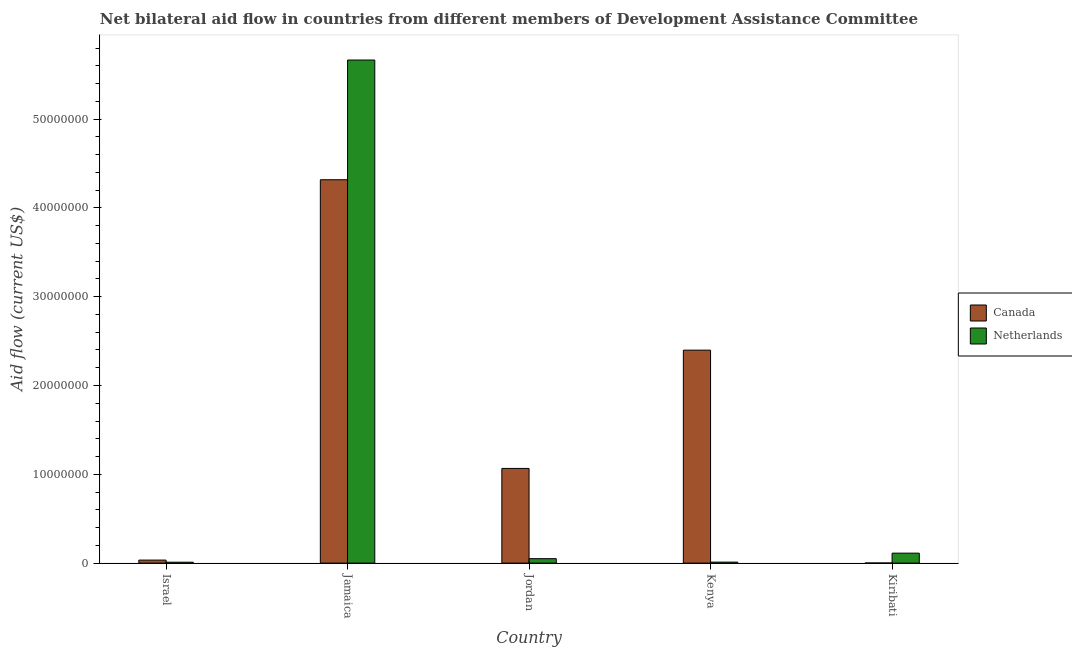What is the label of the 2nd group of bars from the left?
Your response must be concise. Jamaica. What is the amount of aid given by canada in Israel?
Your answer should be very brief. 3.40e+05. Across all countries, what is the maximum amount of aid given by netherlands?
Ensure brevity in your answer.  5.66e+07. Across all countries, what is the minimum amount of aid given by canada?
Your answer should be compact. 10000. In which country was the amount of aid given by netherlands maximum?
Keep it short and to the point. Jamaica. In which country was the amount of aid given by canada minimum?
Make the answer very short. Kiribati. What is the total amount of aid given by netherlands in the graph?
Your answer should be very brief. 5.85e+07. What is the difference between the amount of aid given by netherlands in Jamaica and that in Kiribati?
Your answer should be compact. 5.55e+07. What is the difference between the amount of aid given by netherlands in Kenya and the amount of aid given by canada in Jamaica?
Keep it short and to the point. -4.31e+07. What is the average amount of aid given by netherlands per country?
Provide a short and direct response. 1.17e+07. What is the difference between the amount of aid given by netherlands and amount of aid given by canada in Jordan?
Make the answer very short. -1.02e+07. In how many countries, is the amount of aid given by canada greater than 44000000 US$?
Your response must be concise. 0. What is the ratio of the amount of aid given by canada in Jamaica to that in Kenya?
Provide a succinct answer. 1.8. Is the amount of aid given by canada in Israel less than that in Jordan?
Ensure brevity in your answer.  Yes. Is the difference between the amount of aid given by netherlands in Israel and Kiribati greater than the difference between the amount of aid given by canada in Israel and Kiribati?
Make the answer very short. No. What is the difference between the highest and the second highest amount of aid given by canada?
Your response must be concise. 1.92e+07. What is the difference between the highest and the lowest amount of aid given by netherlands?
Provide a short and direct response. 5.66e+07. What does the 1st bar from the right in Kenya represents?
Ensure brevity in your answer.  Netherlands. How many bars are there?
Ensure brevity in your answer.  10. Are all the bars in the graph horizontal?
Provide a short and direct response. No. How many countries are there in the graph?
Keep it short and to the point. 5. Does the graph contain any zero values?
Your answer should be compact. No. Where does the legend appear in the graph?
Offer a very short reply. Center right. What is the title of the graph?
Give a very brief answer. Net bilateral aid flow in countries from different members of Development Assistance Committee. Does "All education staff compensation" appear as one of the legend labels in the graph?
Provide a short and direct response. No. What is the label or title of the X-axis?
Offer a terse response. Country. What is the Aid flow (current US$) of Canada in Israel?
Offer a very short reply. 3.40e+05. What is the Aid flow (current US$) of Netherlands in Israel?
Offer a terse response. 1.00e+05. What is the Aid flow (current US$) of Canada in Jamaica?
Provide a short and direct response. 4.32e+07. What is the Aid flow (current US$) in Netherlands in Jamaica?
Provide a short and direct response. 5.66e+07. What is the Aid flow (current US$) of Canada in Jordan?
Your answer should be very brief. 1.07e+07. What is the Aid flow (current US$) in Canada in Kenya?
Provide a short and direct response. 2.40e+07. What is the Aid flow (current US$) of Netherlands in Kenya?
Your answer should be very brief. 1.10e+05. What is the Aid flow (current US$) in Canada in Kiribati?
Offer a very short reply. 10000. What is the Aid flow (current US$) in Netherlands in Kiribati?
Provide a short and direct response. 1.12e+06. Across all countries, what is the maximum Aid flow (current US$) of Canada?
Offer a very short reply. 4.32e+07. Across all countries, what is the maximum Aid flow (current US$) of Netherlands?
Your answer should be very brief. 5.66e+07. What is the total Aid flow (current US$) in Canada in the graph?
Give a very brief answer. 7.82e+07. What is the total Aid flow (current US$) of Netherlands in the graph?
Ensure brevity in your answer.  5.85e+07. What is the difference between the Aid flow (current US$) of Canada in Israel and that in Jamaica?
Your answer should be compact. -4.28e+07. What is the difference between the Aid flow (current US$) in Netherlands in Israel and that in Jamaica?
Ensure brevity in your answer.  -5.66e+07. What is the difference between the Aid flow (current US$) in Canada in Israel and that in Jordan?
Make the answer very short. -1.03e+07. What is the difference between the Aid flow (current US$) in Netherlands in Israel and that in Jordan?
Your answer should be compact. -4.00e+05. What is the difference between the Aid flow (current US$) in Canada in Israel and that in Kenya?
Your response must be concise. -2.36e+07. What is the difference between the Aid flow (current US$) of Netherlands in Israel and that in Kenya?
Provide a short and direct response. -10000. What is the difference between the Aid flow (current US$) of Canada in Israel and that in Kiribati?
Your response must be concise. 3.30e+05. What is the difference between the Aid flow (current US$) in Netherlands in Israel and that in Kiribati?
Give a very brief answer. -1.02e+06. What is the difference between the Aid flow (current US$) in Canada in Jamaica and that in Jordan?
Offer a terse response. 3.25e+07. What is the difference between the Aid flow (current US$) of Netherlands in Jamaica and that in Jordan?
Offer a very short reply. 5.62e+07. What is the difference between the Aid flow (current US$) in Canada in Jamaica and that in Kenya?
Keep it short and to the point. 1.92e+07. What is the difference between the Aid flow (current US$) of Netherlands in Jamaica and that in Kenya?
Your answer should be very brief. 5.65e+07. What is the difference between the Aid flow (current US$) of Canada in Jamaica and that in Kiribati?
Your response must be concise. 4.32e+07. What is the difference between the Aid flow (current US$) in Netherlands in Jamaica and that in Kiribati?
Give a very brief answer. 5.55e+07. What is the difference between the Aid flow (current US$) of Canada in Jordan and that in Kenya?
Your answer should be very brief. -1.33e+07. What is the difference between the Aid flow (current US$) of Canada in Jordan and that in Kiribati?
Keep it short and to the point. 1.06e+07. What is the difference between the Aid flow (current US$) in Netherlands in Jordan and that in Kiribati?
Ensure brevity in your answer.  -6.20e+05. What is the difference between the Aid flow (current US$) of Canada in Kenya and that in Kiribati?
Keep it short and to the point. 2.40e+07. What is the difference between the Aid flow (current US$) in Netherlands in Kenya and that in Kiribati?
Your response must be concise. -1.01e+06. What is the difference between the Aid flow (current US$) in Canada in Israel and the Aid flow (current US$) in Netherlands in Jamaica?
Make the answer very short. -5.63e+07. What is the difference between the Aid flow (current US$) of Canada in Israel and the Aid flow (current US$) of Netherlands in Jordan?
Make the answer very short. -1.60e+05. What is the difference between the Aid flow (current US$) in Canada in Israel and the Aid flow (current US$) in Netherlands in Kiribati?
Ensure brevity in your answer.  -7.80e+05. What is the difference between the Aid flow (current US$) of Canada in Jamaica and the Aid flow (current US$) of Netherlands in Jordan?
Your response must be concise. 4.27e+07. What is the difference between the Aid flow (current US$) of Canada in Jamaica and the Aid flow (current US$) of Netherlands in Kenya?
Make the answer very short. 4.31e+07. What is the difference between the Aid flow (current US$) of Canada in Jamaica and the Aid flow (current US$) of Netherlands in Kiribati?
Your answer should be compact. 4.20e+07. What is the difference between the Aid flow (current US$) in Canada in Jordan and the Aid flow (current US$) in Netherlands in Kenya?
Your answer should be compact. 1.06e+07. What is the difference between the Aid flow (current US$) of Canada in Jordan and the Aid flow (current US$) of Netherlands in Kiribati?
Offer a terse response. 9.54e+06. What is the difference between the Aid flow (current US$) in Canada in Kenya and the Aid flow (current US$) in Netherlands in Kiribati?
Give a very brief answer. 2.29e+07. What is the average Aid flow (current US$) of Canada per country?
Offer a terse response. 1.56e+07. What is the average Aid flow (current US$) of Netherlands per country?
Your answer should be very brief. 1.17e+07. What is the difference between the Aid flow (current US$) in Canada and Aid flow (current US$) in Netherlands in Israel?
Give a very brief answer. 2.40e+05. What is the difference between the Aid flow (current US$) in Canada and Aid flow (current US$) in Netherlands in Jamaica?
Offer a terse response. -1.35e+07. What is the difference between the Aid flow (current US$) in Canada and Aid flow (current US$) in Netherlands in Jordan?
Offer a terse response. 1.02e+07. What is the difference between the Aid flow (current US$) in Canada and Aid flow (current US$) in Netherlands in Kenya?
Give a very brief answer. 2.39e+07. What is the difference between the Aid flow (current US$) in Canada and Aid flow (current US$) in Netherlands in Kiribati?
Your response must be concise. -1.11e+06. What is the ratio of the Aid flow (current US$) in Canada in Israel to that in Jamaica?
Provide a short and direct response. 0.01. What is the ratio of the Aid flow (current US$) in Netherlands in Israel to that in Jamaica?
Provide a short and direct response. 0. What is the ratio of the Aid flow (current US$) of Canada in Israel to that in Jordan?
Ensure brevity in your answer.  0.03. What is the ratio of the Aid flow (current US$) of Canada in Israel to that in Kenya?
Your response must be concise. 0.01. What is the ratio of the Aid flow (current US$) of Canada in Israel to that in Kiribati?
Your answer should be compact. 34. What is the ratio of the Aid flow (current US$) in Netherlands in Israel to that in Kiribati?
Ensure brevity in your answer.  0.09. What is the ratio of the Aid flow (current US$) in Canada in Jamaica to that in Jordan?
Your answer should be compact. 4.05. What is the ratio of the Aid flow (current US$) of Netherlands in Jamaica to that in Jordan?
Your response must be concise. 113.3. What is the ratio of the Aid flow (current US$) of Canada in Jamaica to that in Kenya?
Give a very brief answer. 1.8. What is the ratio of the Aid flow (current US$) in Netherlands in Jamaica to that in Kenya?
Offer a very short reply. 515. What is the ratio of the Aid flow (current US$) of Canada in Jamaica to that in Kiribati?
Offer a terse response. 4317. What is the ratio of the Aid flow (current US$) in Netherlands in Jamaica to that in Kiribati?
Make the answer very short. 50.58. What is the ratio of the Aid flow (current US$) in Canada in Jordan to that in Kenya?
Give a very brief answer. 0.44. What is the ratio of the Aid flow (current US$) in Netherlands in Jordan to that in Kenya?
Provide a succinct answer. 4.55. What is the ratio of the Aid flow (current US$) in Canada in Jordan to that in Kiribati?
Give a very brief answer. 1066. What is the ratio of the Aid flow (current US$) of Netherlands in Jordan to that in Kiribati?
Your response must be concise. 0.45. What is the ratio of the Aid flow (current US$) in Canada in Kenya to that in Kiribati?
Provide a short and direct response. 2398. What is the ratio of the Aid flow (current US$) in Netherlands in Kenya to that in Kiribati?
Your response must be concise. 0.1. What is the difference between the highest and the second highest Aid flow (current US$) in Canada?
Provide a succinct answer. 1.92e+07. What is the difference between the highest and the second highest Aid flow (current US$) in Netherlands?
Provide a short and direct response. 5.55e+07. What is the difference between the highest and the lowest Aid flow (current US$) in Canada?
Offer a very short reply. 4.32e+07. What is the difference between the highest and the lowest Aid flow (current US$) in Netherlands?
Your response must be concise. 5.66e+07. 